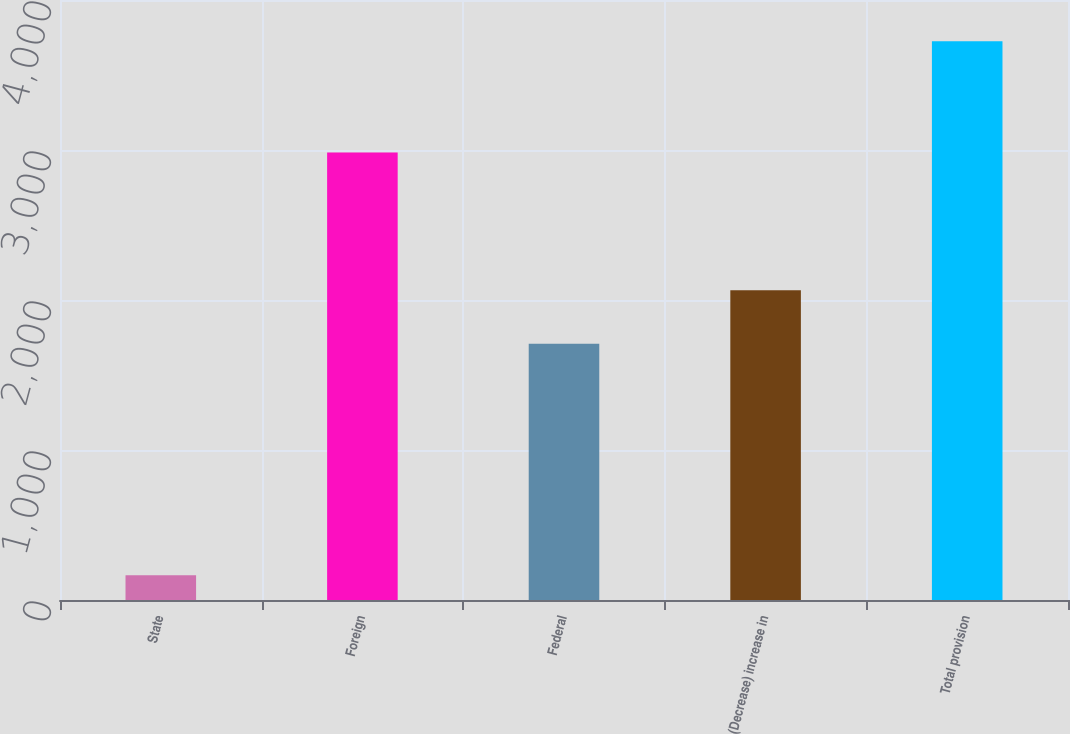<chart> <loc_0><loc_0><loc_500><loc_500><bar_chart><fcel>State<fcel>Foreign<fcel>Federal<fcel>(Decrease) increase in<fcel>Total provision<nl><fcel>165<fcel>2984<fcel>1709<fcel>2065<fcel>3725<nl></chart> 